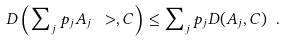<formula> <loc_0><loc_0><loc_500><loc_500>D \left ( \sum \nolimits _ { j } p _ { j } { A } _ { j } \ > , { C } \right ) \leq \sum \nolimits _ { j } p _ { j } D ( { A } _ { j } , { C } ) \ .</formula> 